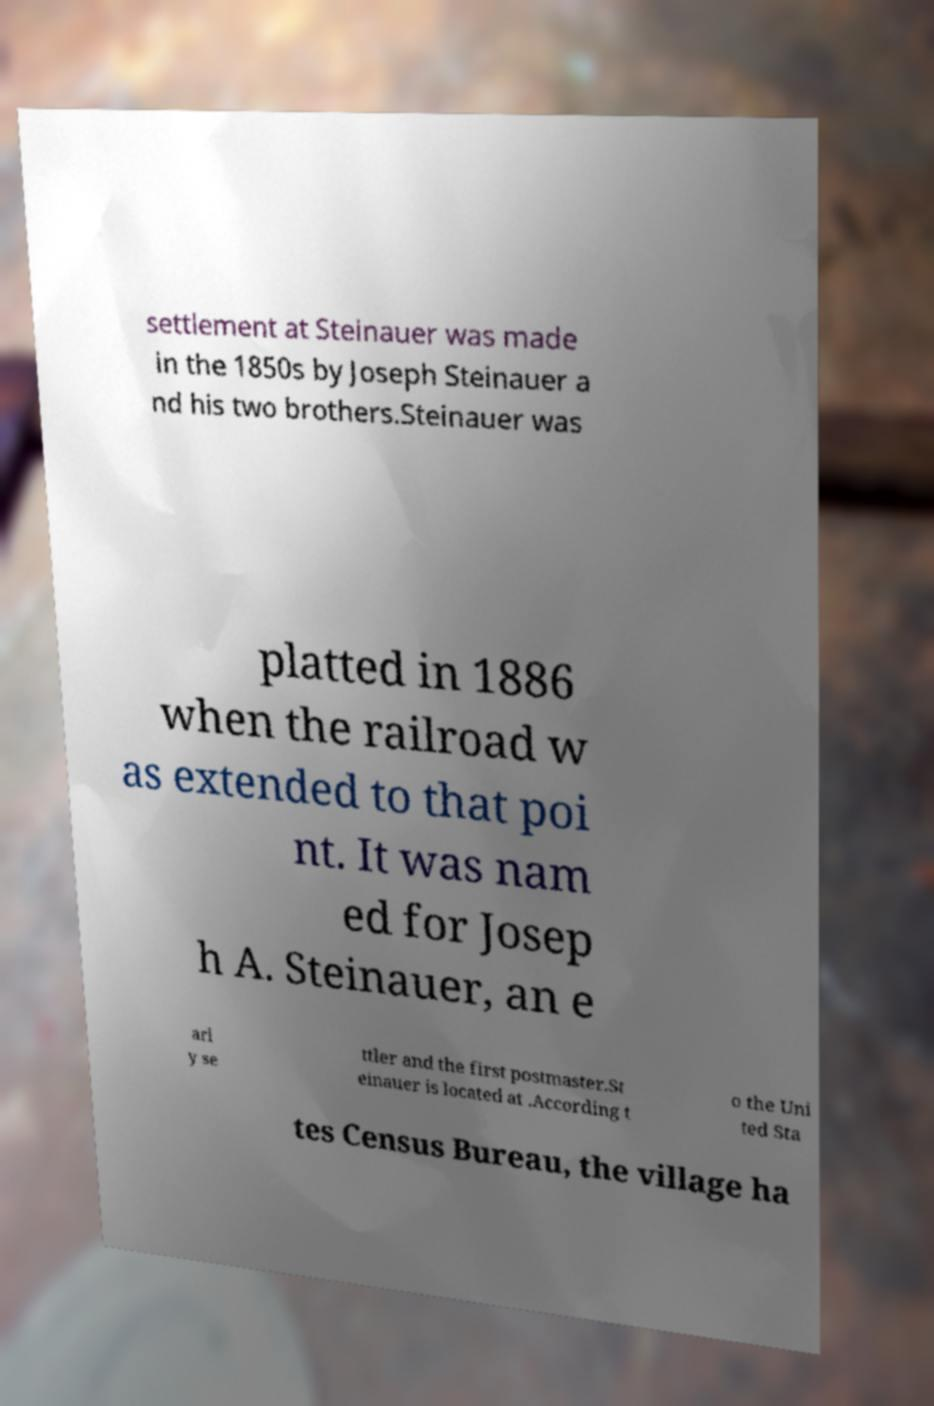Can you read and provide the text displayed in the image?This photo seems to have some interesting text. Can you extract and type it out for me? settlement at Steinauer was made in the 1850s by Joseph Steinauer a nd his two brothers.Steinauer was platted in 1886 when the railroad w as extended to that poi nt. It was nam ed for Josep h A. Steinauer, an e arl y se ttler and the first postmaster.St einauer is located at .According t o the Uni ted Sta tes Census Bureau, the village ha 